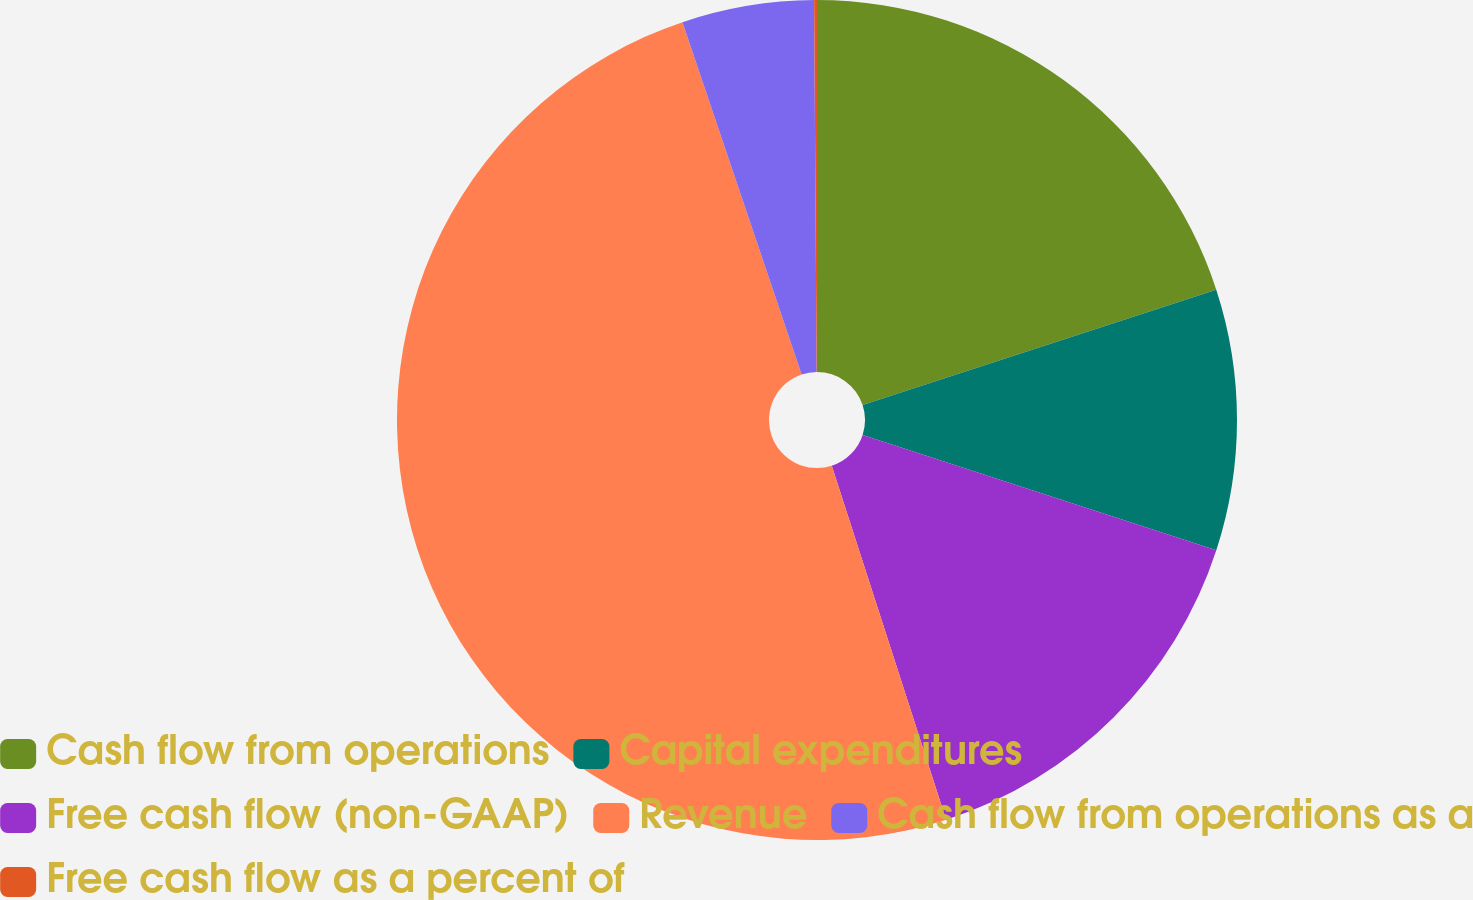Convert chart to OTSL. <chart><loc_0><loc_0><loc_500><loc_500><pie_chart><fcel>Cash flow from operations<fcel>Capital expenditures<fcel>Free cash flow (non-GAAP)<fcel>Revenue<fcel>Cash flow from operations as a<fcel>Free cash flow as a percent of<nl><fcel>19.98%<fcel>10.04%<fcel>15.01%<fcel>49.79%<fcel>5.08%<fcel>0.11%<nl></chart> 